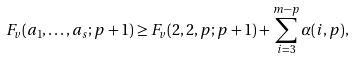<formula> <loc_0><loc_0><loc_500><loc_500>F _ { v } ( a _ { 1 } , \dots , a _ { s } ; p + 1 ) \geq F _ { v } ( 2 , 2 , p ; p + 1 ) + \sum _ { i = 3 } ^ { m - p } \alpha ( i , p ) ,</formula> 